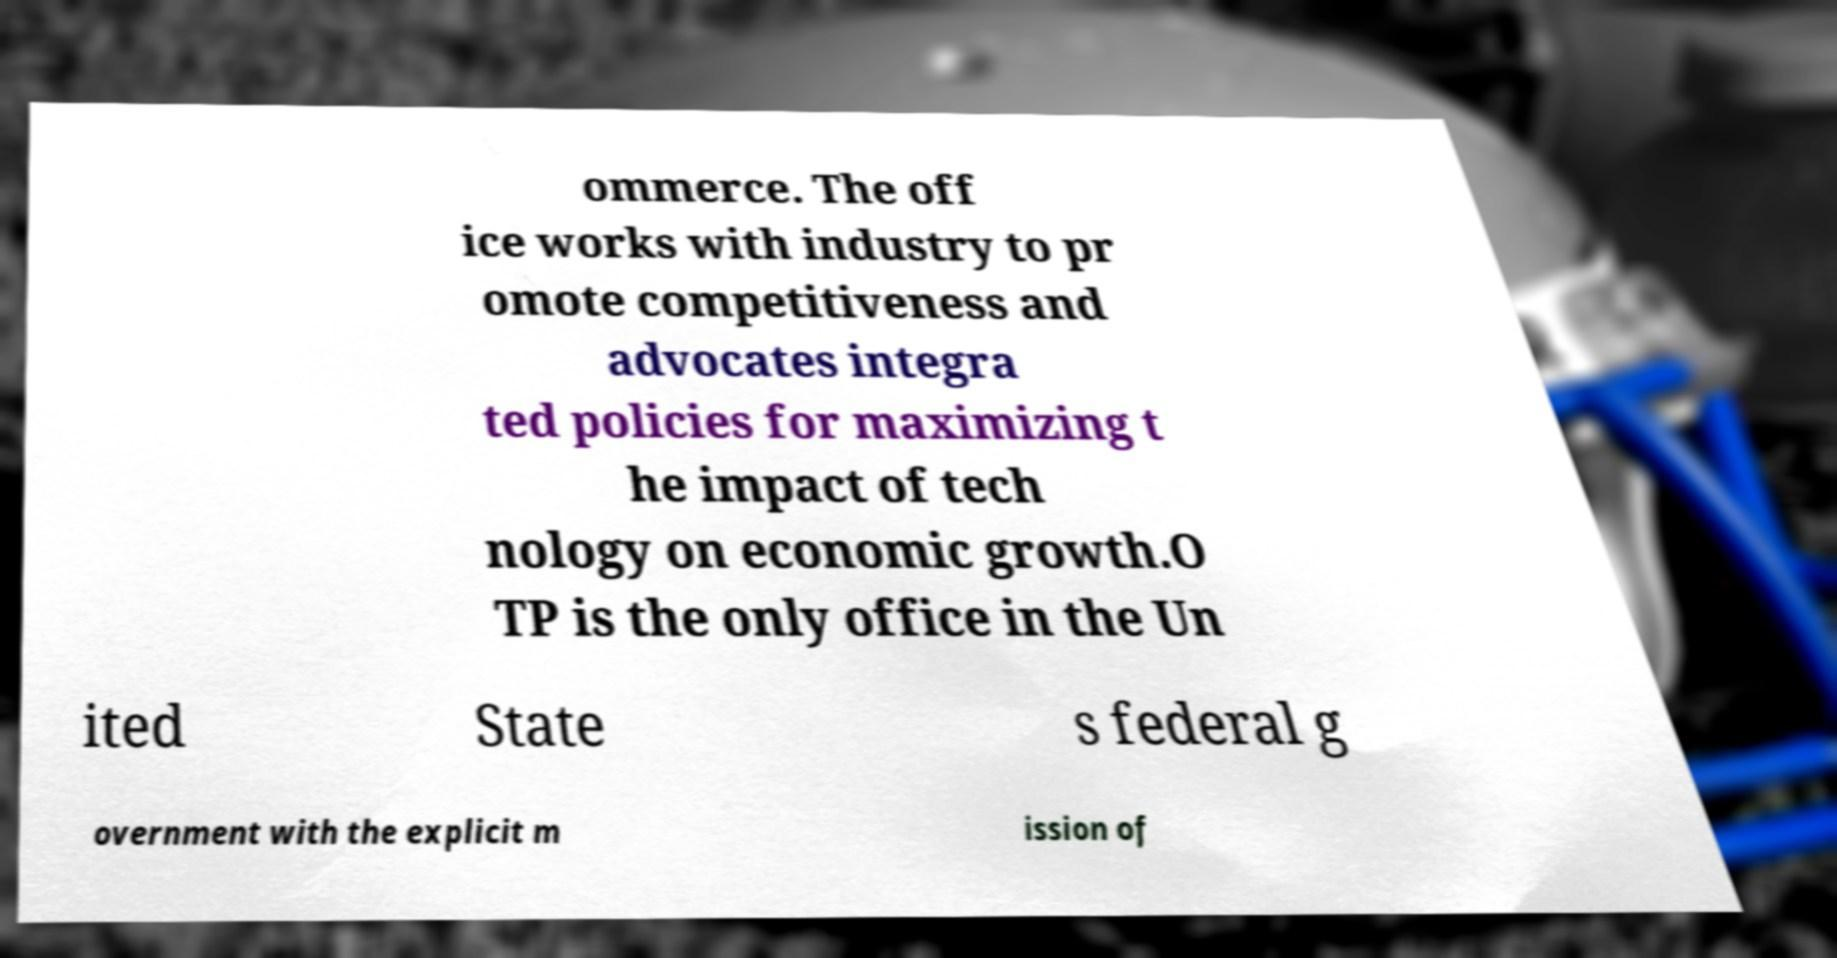For documentation purposes, I need the text within this image transcribed. Could you provide that? ommerce. The off ice works with industry to pr omote competitiveness and advocates integra ted policies for maximizing t he impact of tech nology on economic growth.O TP is the only office in the Un ited State s federal g overnment with the explicit m ission of 